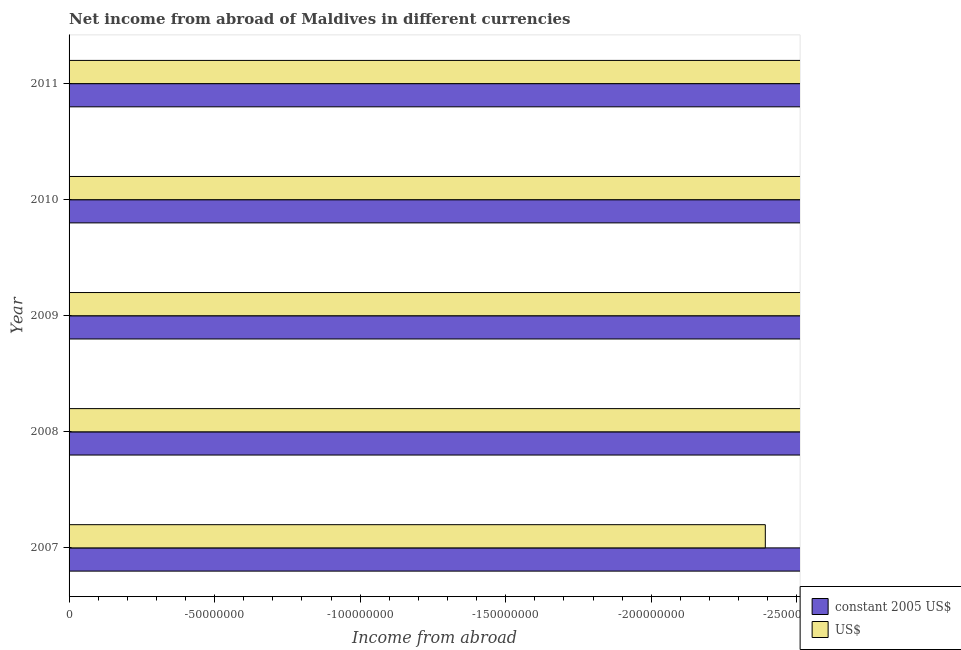How many different coloured bars are there?
Offer a terse response. 0. Are the number of bars on each tick of the Y-axis equal?
Offer a terse response. Yes. How many bars are there on the 2nd tick from the top?
Your answer should be very brief. 0. How many bars are there on the 4th tick from the bottom?
Give a very brief answer. 0. What is the label of the 3rd group of bars from the top?
Keep it short and to the point. 2009. What is the difference between the income from abroad in us$ in 2007 and the income from abroad in constant 2005 us$ in 2010?
Your answer should be compact. 0. What is the average income from abroad in us$ per year?
Your answer should be very brief. 0. In how many years, is the income from abroad in constant 2005 us$ greater than -180000000 units?
Provide a succinct answer. 0. In how many years, is the income from abroad in us$ greater than the average income from abroad in us$ taken over all years?
Make the answer very short. 0. How many bars are there?
Provide a succinct answer. 0. Are all the bars in the graph horizontal?
Keep it short and to the point. Yes. What is the difference between two consecutive major ticks on the X-axis?
Offer a terse response. 5.00e+07. Are the values on the major ticks of X-axis written in scientific E-notation?
Your response must be concise. No. Does the graph contain any zero values?
Keep it short and to the point. Yes. Where does the legend appear in the graph?
Offer a terse response. Bottom right. How are the legend labels stacked?
Your answer should be very brief. Vertical. What is the title of the graph?
Provide a succinct answer. Net income from abroad of Maldives in different currencies. Does "Male labourers" appear as one of the legend labels in the graph?
Ensure brevity in your answer.  No. What is the label or title of the X-axis?
Your answer should be compact. Income from abroad. What is the Income from abroad of US$ in 2008?
Your response must be concise. 0. What is the Income from abroad of constant 2005 US$ in 2009?
Make the answer very short. 0. What is the Income from abroad in US$ in 2009?
Ensure brevity in your answer.  0. What is the Income from abroad of constant 2005 US$ in 2010?
Offer a very short reply. 0. What is the total Income from abroad of constant 2005 US$ in the graph?
Your answer should be very brief. 0. What is the total Income from abroad of US$ in the graph?
Provide a succinct answer. 0. What is the average Income from abroad of constant 2005 US$ per year?
Your answer should be compact. 0. What is the average Income from abroad of US$ per year?
Your answer should be very brief. 0. 